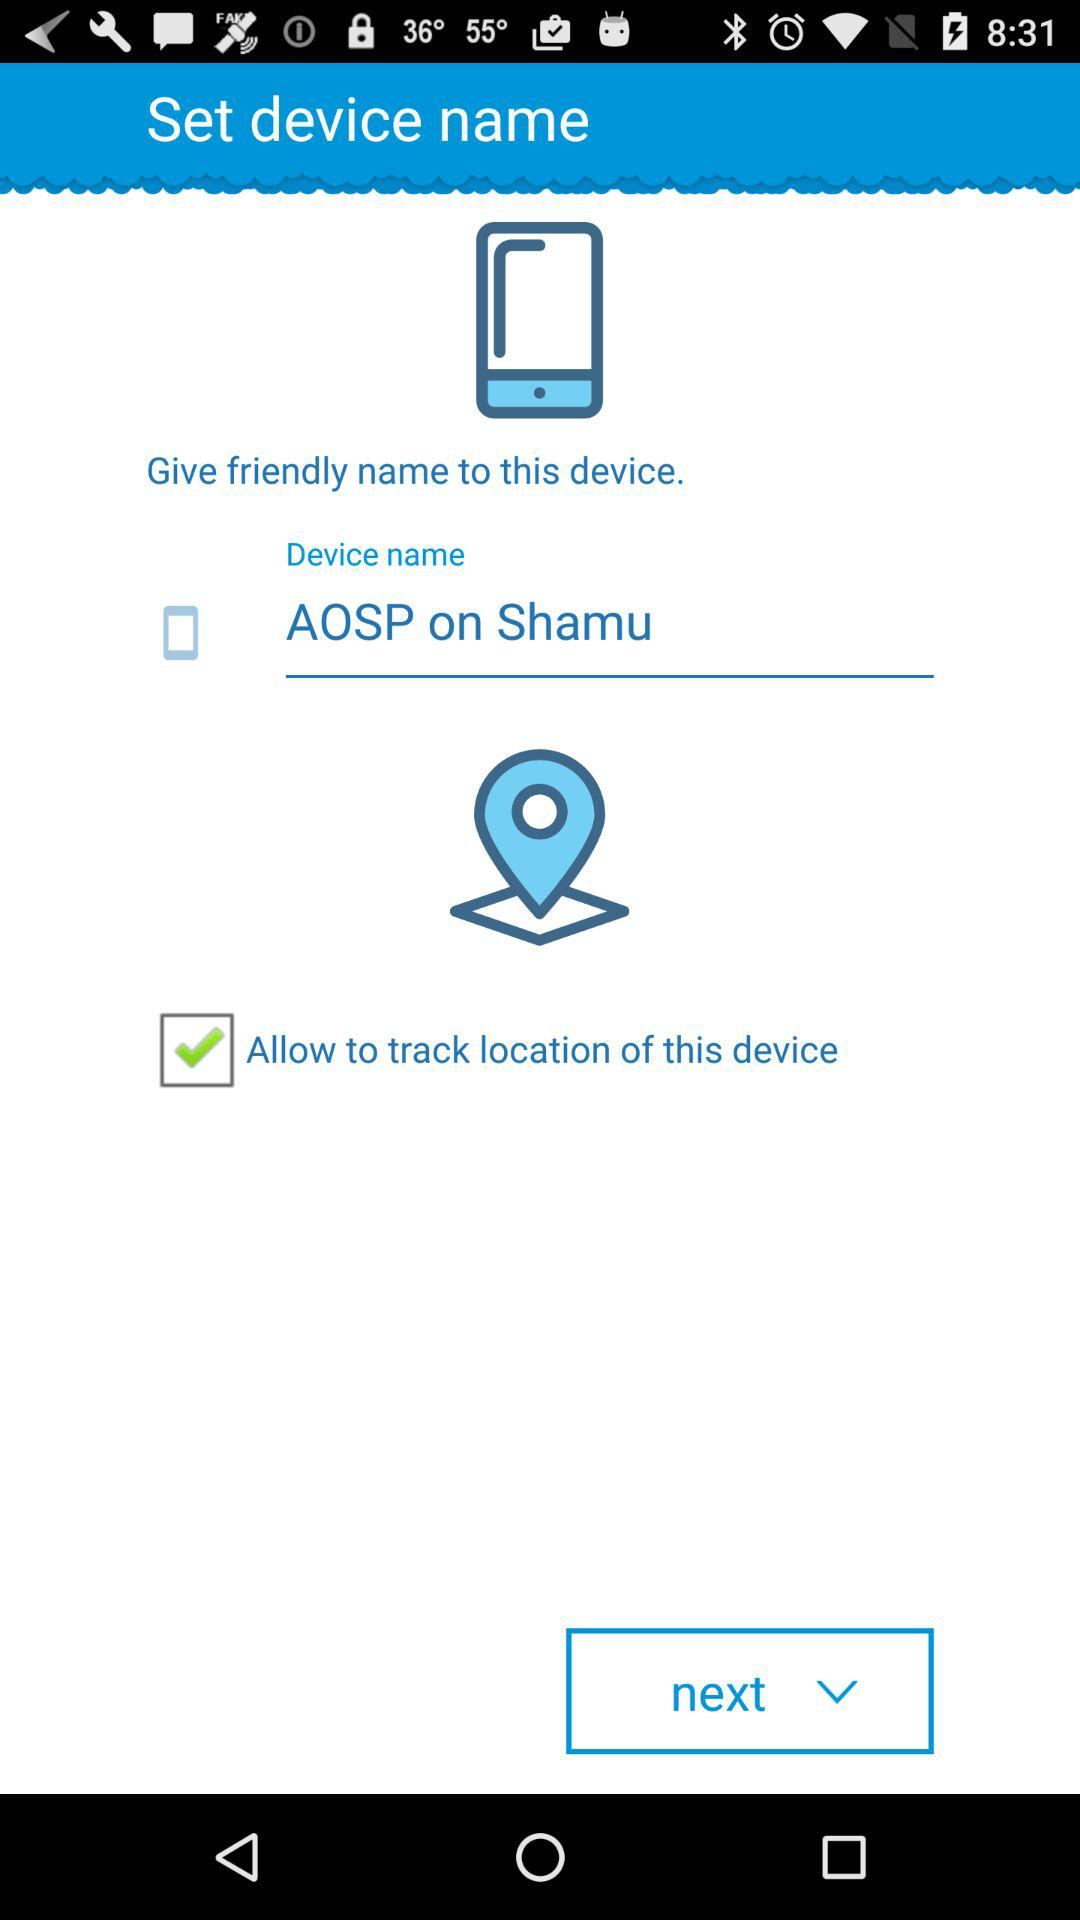How many text inputs are on the screen?
Answer the question using a single word or phrase. 1 